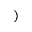Convert formula to latex. <formula><loc_0><loc_0><loc_500><loc_500>)</formula> 